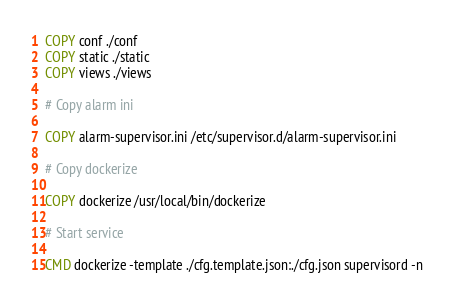Convert code to text. <code><loc_0><loc_0><loc_500><loc_500><_Dockerfile_>COPY conf ./conf
COPY static ./static
COPY views ./views

# Copy alarm ini

COPY alarm-supervisor.ini /etc/supervisor.d/alarm-supervisor.ini

# Copy dockerize

COPY dockerize /usr/local/bin/dockerize

# Start service

CMD dockerize -template ./cfg.template.json:./cfg.json supervisord -n
</code> 